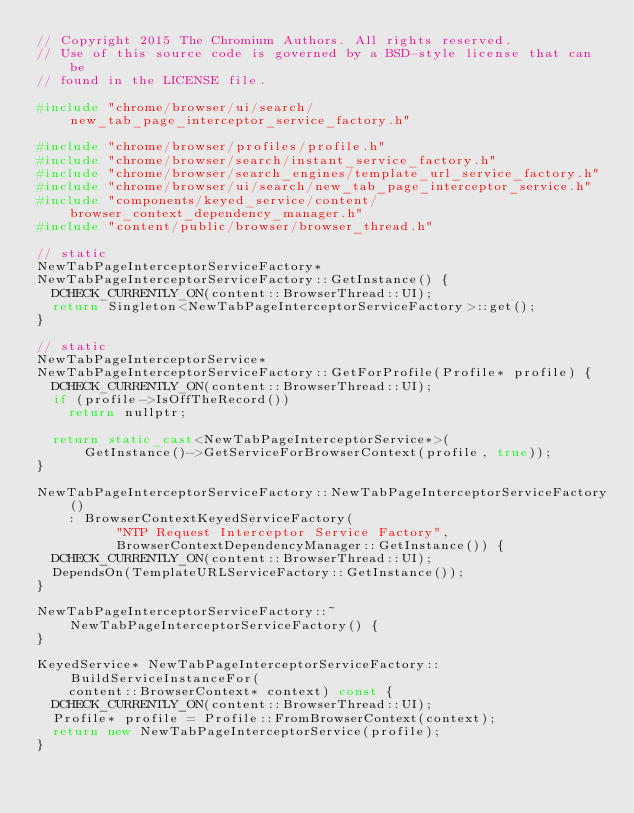Convert code to text. <code><loc_0><loc_0><loc_500><loc_500><_C++_>// Copyright 2015 The Chromium Authors. All rights reserved.
// Use of this source code is governed by a BSD-style license that can be
// found in the LICENSE file.

#include "chrome/browser/ui/search/new_tab_page_interceptor_service_factory.h"

#include "chrome/browser/profiles/profile.h"
#include "chrome/browser/search/instant_service_factory.h"
#include "chrome/browser/search_engines/template_url_service_factory.h"
#include "chrome/browser/ui/search/new_tab_page_interceptor_service.h"
#include "components/keyed_service/content/browser_context_dependency_manager.h"
#include "content/public/browser/browser_thread.h"

// static
NewTabPageInterceptorServiceFactory*
NewTabPageInterceptorServiceFactory::GetInstance() {
  DCHECK_CURRENTLY_ON(content::BrowserThread::UI);
  return Singleton<NewTabPageInterceptorServiceFactory>::get();
}

// static
NewTabPageInterceptorService*
NewTabPageInterceptorServiceFactory::GetForProfile(Profile* profile) {
  DCHECK_CURRENTLY_ON(content::BrowserThread::UI);
  if (profile->IsOffTheRecord())
    return nullptr;

  return static_cast<NewTabPageInterceptorService*>(
      GetInstance()->GetServiceForBrowserContext(profile, true));
}

NewTabPageInterceptorServiceFactory::NewTabPageInterceptorServiceFactory()
    : BrowserContextKeyedServiceFactory(
          "NTP Request Interceptor Service Factory",
          BrowserContextDependencyManager::GetInstance()) {
  DCHECK_CURRENTLY_ON(content::BrowserThread::UI);
  DependsOn(TemplateURLServiceFactory::GetInstance());
}

NewTabPageInterceptorServiceFactory::~NewTabPageInterceptorServiceFactory() {
}

KeyedService* NewTabPageInterceptorServiceFactory::BuildServiceInstanceFor(
    content::BrowserContext* context) const {
  DCHECK_CURRENTLY_ON(content::BrowserThread::UI);
  Profile* profile = Profile::FromBrowserContext(context);
  return new NewTabPageInterceptorService(profile);
}
</code> 